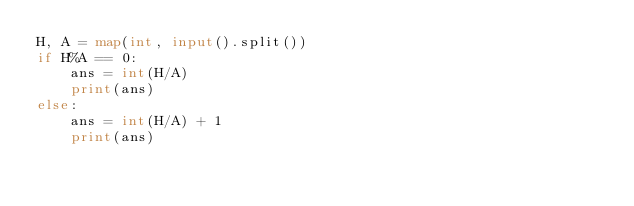<code> <loc_0><loc_0><loc_500><loc_500><_Python_>H, A = map(int, input().split())
if H%A == 0:
    ans = int(H/A)
    print(ans)
else:
    ans = int(H/A) + 1
    print(ans)</code> 